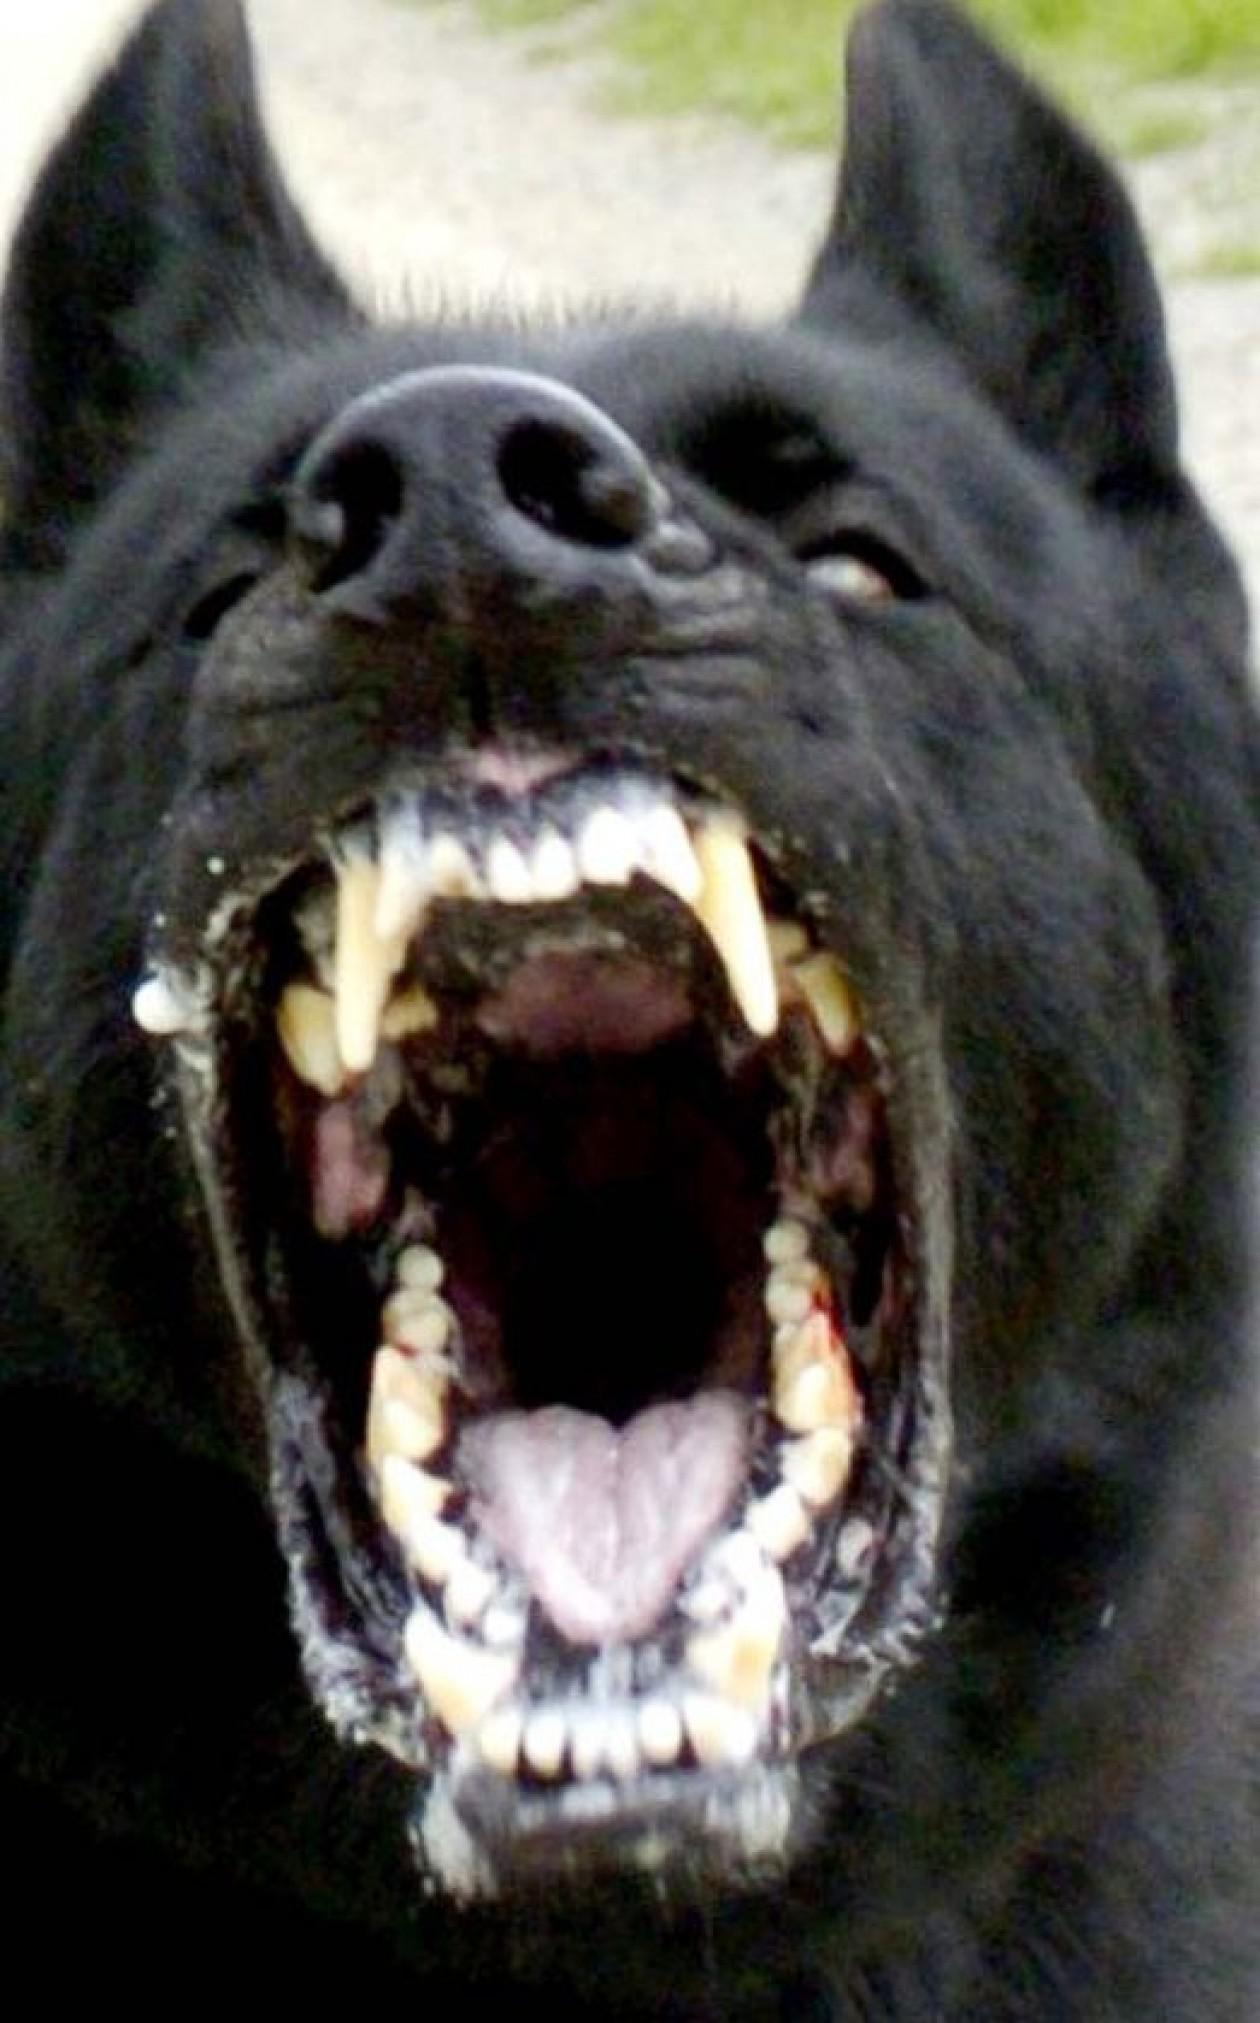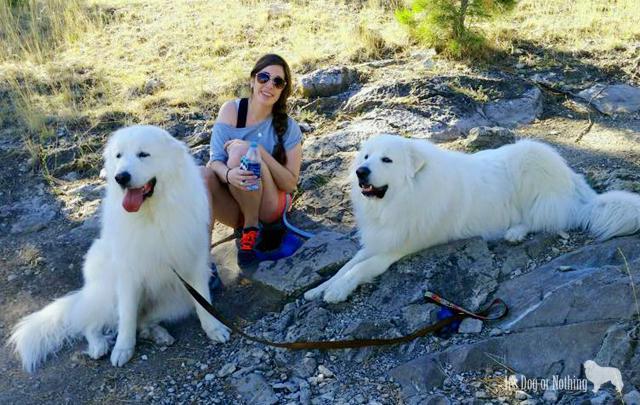The first image is the image on the left, the second image is the image on the right. Examine the images to the left and right. Is the description "A girl wearing a blue shirt and sunglasses is sitting in between 2 large white dogs." accurate? Answer yes or no. Yes. 